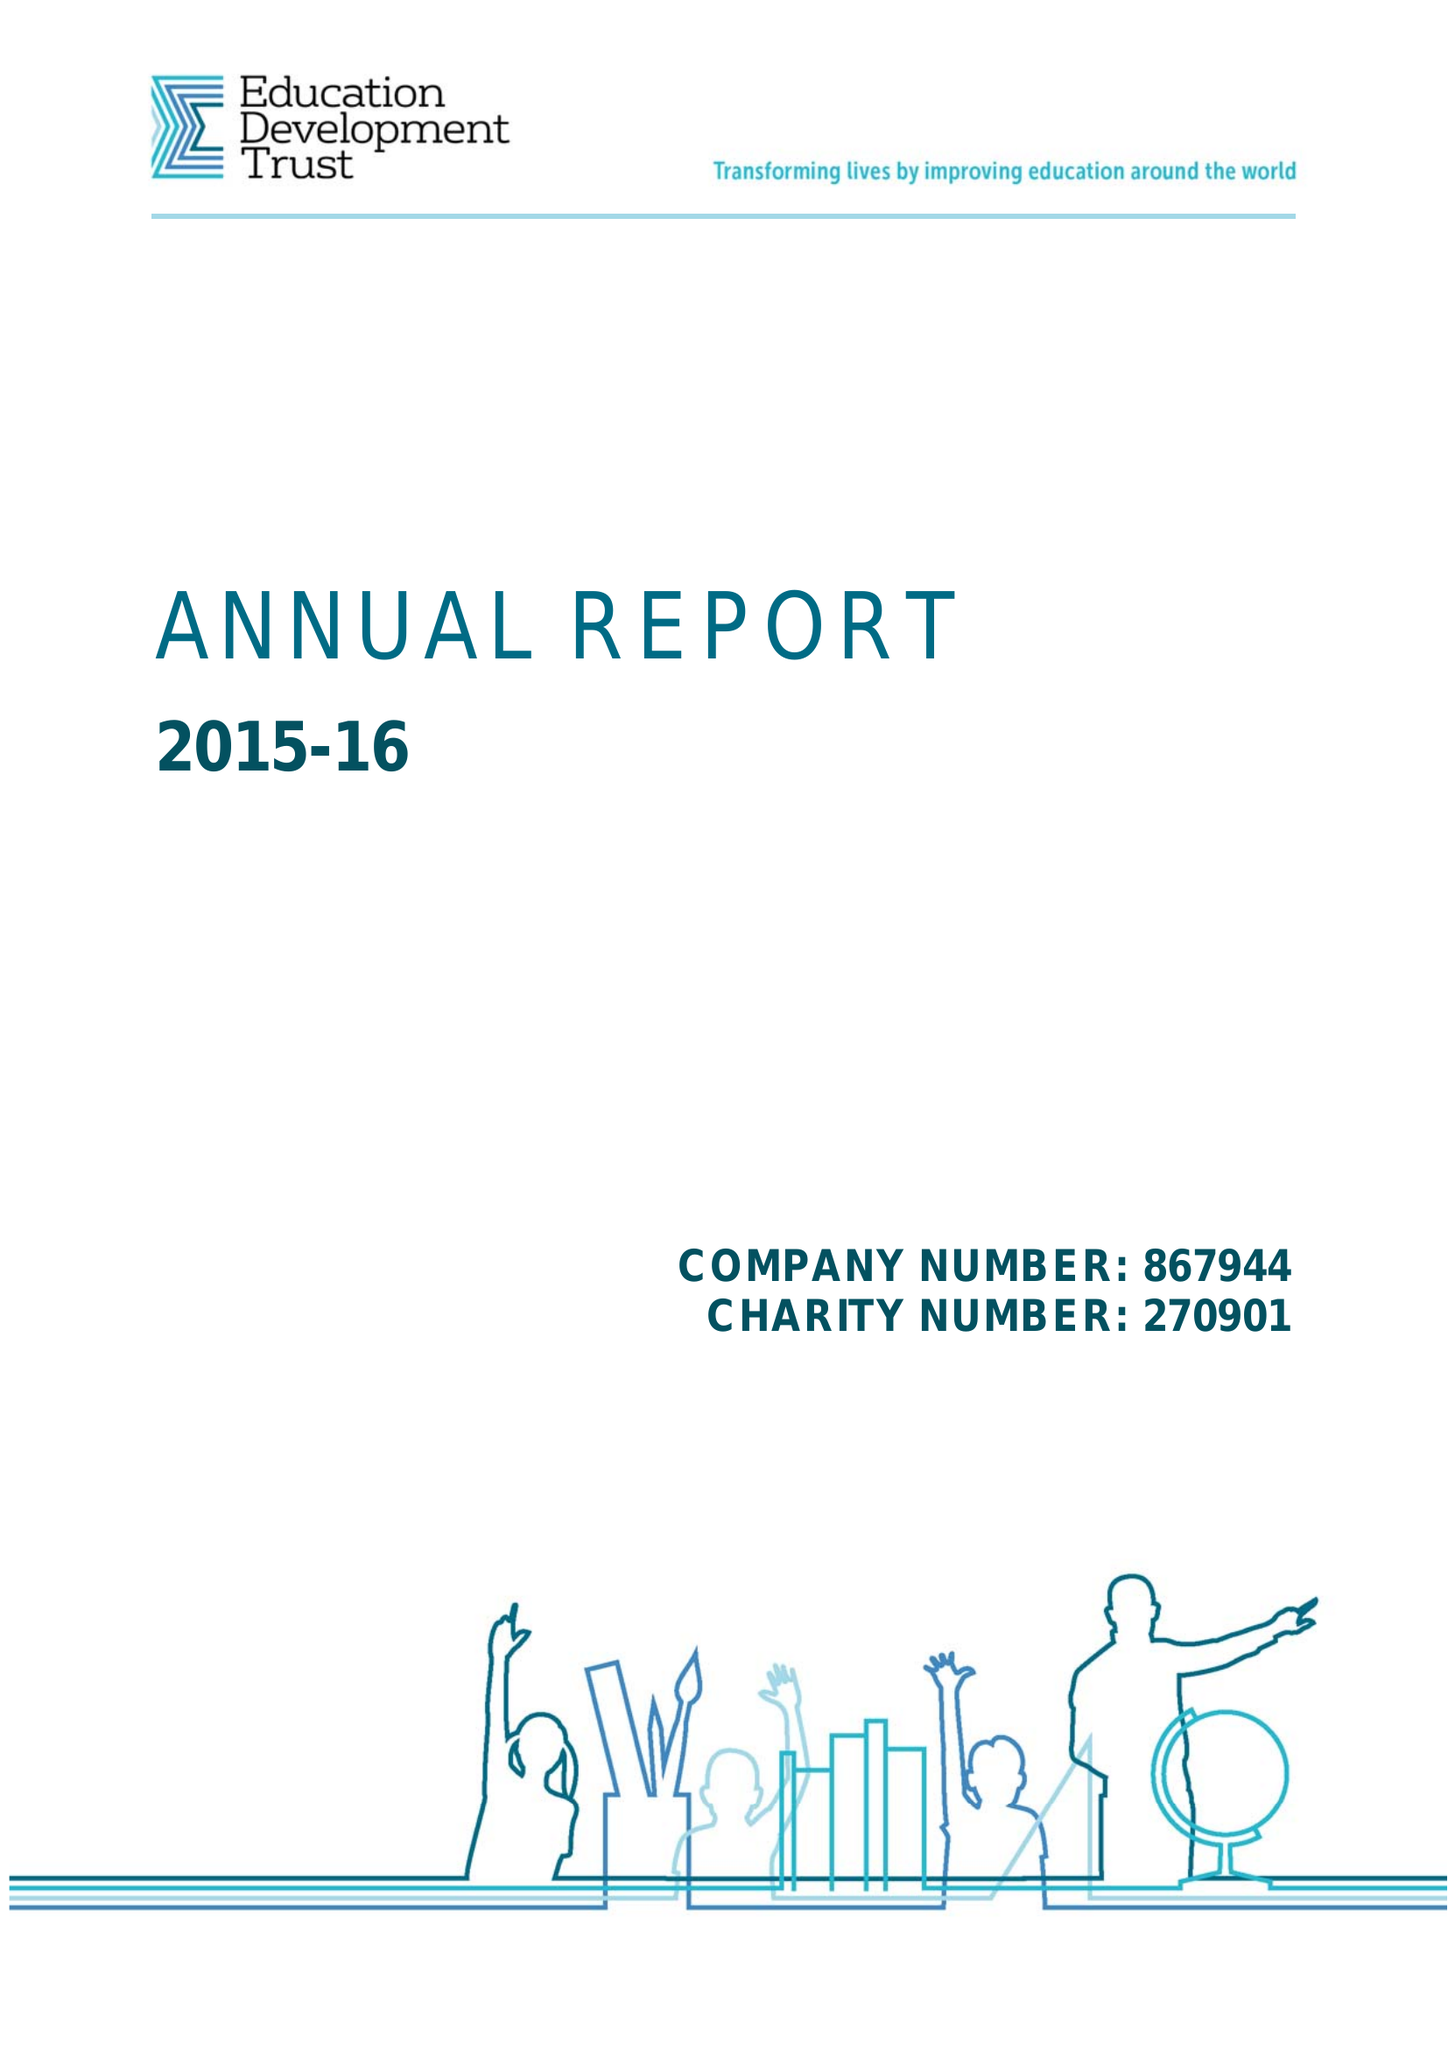What is the value for the charity_name?
Answer the question using a single word or phrase. Education Development Trust 